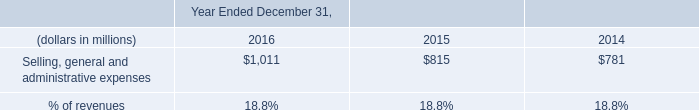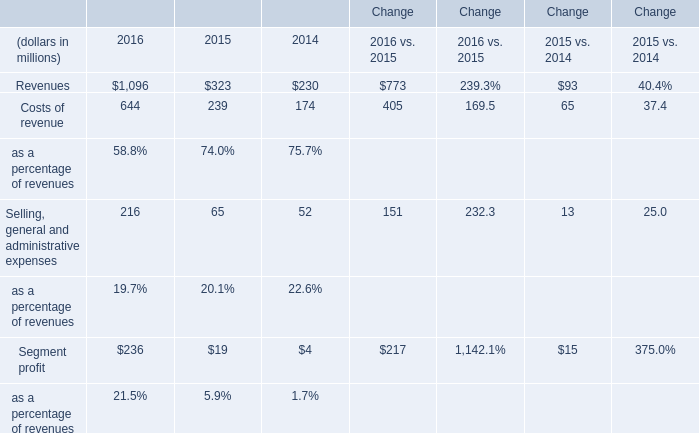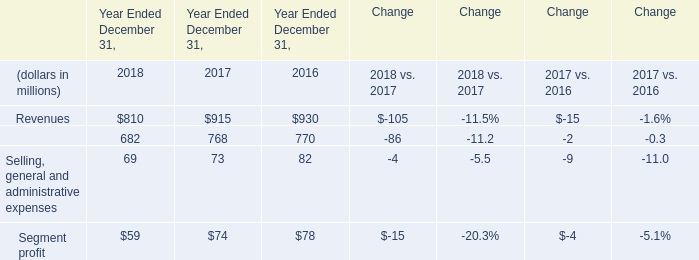What is the growing rate of Segment profit in the year with the most Selling, general and administrative expenses? 
Computations: ((236 - 19) / 19)
Answer: 11.42105. 